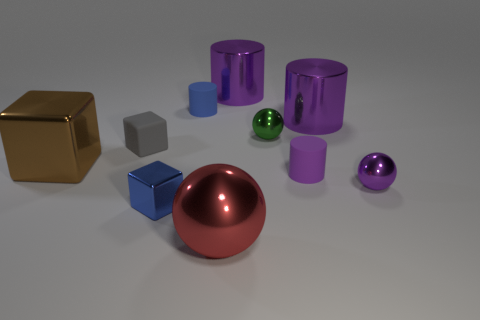Subtract all cyan balls. How many purple cylinders are left? 3 Subtract 1 balls. How many balls are left? 2 Subtract all green cylinders. Subtract all gray blocks. How many cylinders are left? 4 Subtract all blocks. How many objects are left? 7 Add 2 gray matte things. How many gray matte things exist? 3 Subtract 0 brown cylinders. How many objects are left? 10 Subtract all tiny purple balls. Subtract all tiny blue metallic blocks. How many objects are left? 8 Add 2 blue cylinders. How many blue cylinders are left? 3 